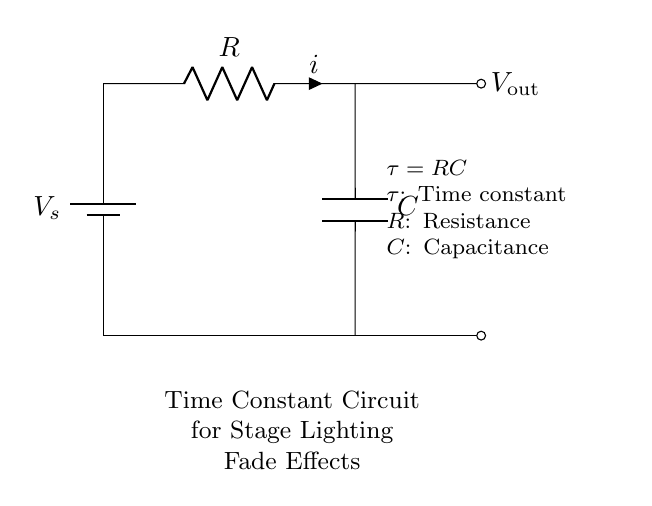What components are present in this circuit? The circuit includes a battery, a resistor, and a capacitor, which are essential for establishing the time constant behavior necessary for fading effects in stage lighting.
Answer: battery, resistor, capacitor What does the symbol 'C' represent? The symbol 'C' in the circuit diagram indicates a capacitor, which stores electrical energy and influences the time constant for the fading effect.
Answer: capacitor What is the equation for the time constant in this circuit? The time constant equation is given as τ = RC, where τ represents the time constant, R is the resistance, and C is the capacitance in the circuit.
Answer: τ = RC How does increasing the resistance affect the time constant? Increasing the resistance will lead to a larger time constant, making the fading effect slower because the time constant τ = RC suggests that a higher R results in a longer time for the voltage to change across the capacitor.
Answer: slower What happens to the output voltage as time progresses in this circuit? The output voltage decreases over time as the capacitor discharges, following an exponential decay governed by the time constant τ, ultimately approaching zero but not reaching it.
Answer: decreases How does this circuit contribute to stage lighting effects? This resistor-capacitor circuit is used to control the fade time of stage lighting, allowing for smooth transitions by utilizing the time constant which determines how quickly the light intensity increases or decreases.
Answer: fade control 